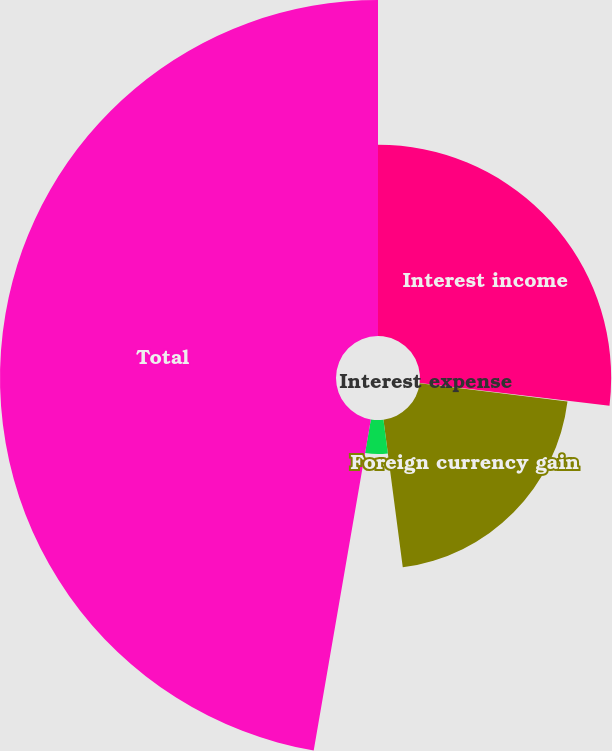<chart> <loc_0><loc_0><loc_500><loc_500><pie_chart><fcel>Interest income<fcel>Interest expense<fcel>Foreign currency gain<fcel>Other<fcel>Total<nl><fcel>26.9%<fcel>0.07%<fcel>20.96%<fcel>4.79%<fcel>47.28%<nl></chart> 